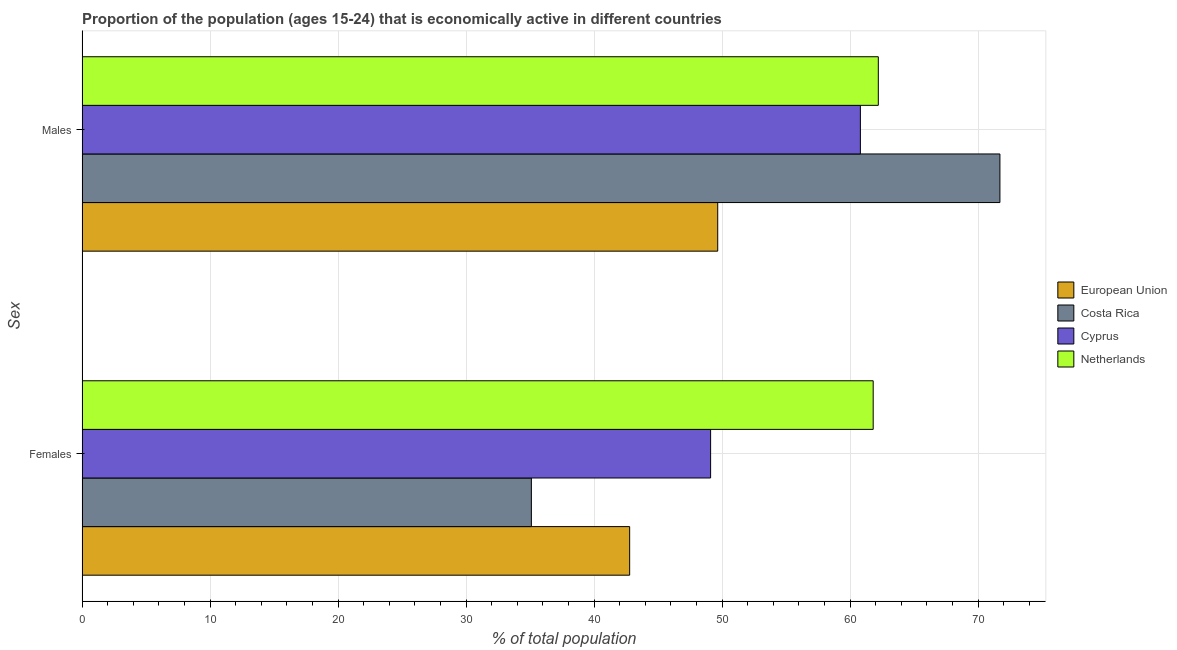How many groups of bars are there?
Make the answer very short. 2. Are the number of bars on each tick of the Y-axis equal?
Give a very brief answer. Yes. How many bars are there on the 1st tick from the bottom?
Ensure brevity in your answer.  4. What is the label of the 1st group of bars from the top?
Offer a very short reply. Males. What is the percentage of economically active female population in European Union?
Make the answer very short. 42.78. Across all countries, what is the maximum percentage of economically active male population?
Your answer should be very brief. 71.7. Across all countries, what is the minimum percentage of economically active male population?
Your response must be concise. 49.66. In which country was the percentage of economically active female population maximum?
Ensure brevity in your answer.  Netherlands. What is the total percentage of economically active male population in the graph?
Your answer should be very brief. 244.36. What is the difference between the percentage of economically active male population in Netherlands and that in European Union?
Make the answer very short. 12.54. What is the difference between the percentage of economically active male population in Netherlands and the percentage of economically active female population in European Union?
Offer a terse response. 19.42. What is the average percentage of economically active female population per country?
Your response must be concise. 47.19. What is the difference between the percentage of economically active male population and percentage of economically active female population in Netherlands?
Make the answer very short. 0.4. What is the ratio of the percentage of economically active male population in Cyprus to that in European Union?
Your answer should be compact. 1.22. What does the 4th bar from the bottom in Males represents?
Provide a succinct answer. Netherlands. How many bars are there?
Your response must be concise. 8. Are all the bars in the graph horizontal?
Your answer should be very brief. Yes. How many countries are there in the graph?
Provide a succinct answer. 4. What is the difference between two consecutive major ticks on the X-axis?
Make the answer very short. 10. How are the legend labels stacked?
Keep it short and to the point. Vertical. What is the title of the graph?
Keep it short and to the point. Proportion of the population (ages 15-24) that is economically active in different countries. Does "Rwanda" appear as one of the legend labels in the graph?
Provide a short and direct response. No. What is the label or title of the X-axis?
Provide a succinct answer. % of total population. What is the label or title of the Y-axis?
Provide a short and direct response. Sex. What is the % of total population in European Union in Females?
Offer a very short reply. 42.78. What is the % of total population in Costa Rica in Females?
Keep it short and to the point. 35.1. What is the % of total population in Cyprus in Females?
Offer a very short reply. 49.1. What is the % of total population in Netherlands in Females?
Your answer should be very brief. 61.8. What is the % of total population of European Union in Males?
Offer a terse response. 49.66. What is the % of total population of Costa Rica in Males?
Offer a very short reply. 71.7. What is the % of total population of Cyprus in Males?
Keep it short and to the point. 60.8. What is the % of total population in Netherlands in Males?
Offer a terse response. 62.2. Across all Sex, what is the maximum % of total population of European Union?
Give a very brief answer. 49.66. Across all Sex, what is the maximum % of total population of Costa Rica?
Offer a very short reply. 71.7. Across all Sex, what is the maximum % of total population in Cyprus?
Give a very brief answer. 60.8. Across all Sex, what is the maximum % of total population of Netherlands?
Give a very brief answer. 62.2. Across all Sex, what is the minimum % of total population in European Union?
Your response must be concise. 42.78. Across all Sex, what is the minimum % of total population of Costa Rica?
Provide a succinct answer. 35.1. Across all Sex, what is the minimum % of total population in Cyprus?
Give a very brief answer. 49.1. Across all Sex, what is the minimum % of total population of Netherlands?
Your answer should be compact. 61.8. What is the total % of total population of European Union in the graph?
Give a very brief answer. 92.43. What is the total % of total population in Costa Rica in the graph?
Provide a short and direct response. 106.8. What is the total % of total population of Cyprus in the graph?
Your answer should be compact. 109.9. What is the total % of total population in Netherlands in the graph?
Give a very brief answer. 124. What is the difference between the % of total population of European Union in Females and that in Males?
Your response must be concise. -6.88. What is the difference between the % of total population in Costa Rica in Females and that in Males?
Offer a very short reply. -36.6. What is the difference between the % of total population of Cyprus in Females and that in Males?
Make the answer very short. -11.7. What is the difference between the % of total population in Netherlands in Females and that in Males?
Provide a short and direct response. -0.4. What is the difference between the % of total population of European Union in Females and the % of total population of Costa Rica in Males?
Ensure brevity in your answer.  -28.92. What is the difference between the % of total population of European Union in Females and the % of total population of Cyprus in Males?
Your response must be concise. -18.02. What is the difference between the % of total population in European Union in Females and the % of total population in Netherlands in Males?
Provide a succinct answer. -19.42. What is the difference between the % of total population in Costa Rica in Females and the % of total population in Cyprus in Males?
Make the answer very short. -25.7. What is the difference between the % of total population in Costa Rica in Females and the % of total population in Netherlands in Males?
Offer a very short reply. -27.1. What is the average % of total population of European Union per Sex?
Keep it short and to the point. 46.22. What is the average % of total population in Costa Rica per Sex?
Provide a short and direct response. 53.4. What is the average % of total population in Cyprus per Sex?
Offer a terse response. 54.95. What is the average % of total population of Netherlands per Sex?
Offer a terse response. 62. What is the difference between the % of total population of European Union and % of total population of Costa Rica in Females?
Keep it short and to the point. 7.68. What is the difference between the % of total population in European Union and % of total population in Cyprus in Females?
Offer a very short reply. -6.32. What is the difference between the % of total population in European Union and % of total population in Netherlands in Females?
Make the answer very short. -19.02. What is the difference between the % of total population of Costa Rica and % of total population of Cyprus in Females?
Provide a short and direct response. -14. What is the difference between the % of total population of Costa Rica and % of total population of Netherlands in Females?
Your answer should be very brief. -26.7. What is the difference between the % of total population in Cyprus and % of total population in Netherlands in Females?
Make the answer very short. -12.7. What is the difference between the % of total population in European Union and % of total population in Costa Rica in Males?
Provide a short and direct response. -22.04. What is the difference between the % of total population in European Union and % of total population in Cyprus in Males?
Keep it short and to the point. -11.14. What is the difference between the % of total population of European Union and % of total population of Netherlands in Males?
Your response must be concise. -12.54. What is the difference between the % of total population in Costa Rica and % of total population in Cyprus in Males?
Ensure brevity in your answer.  10.9. What is the difference between the % of total population of Costa Rica and % of total population of Netherlands in Males?
Make the answer very short. 9.5. What is the difference between the % of total population of Cyprus and % of total population of Netherlands in Males?
Provide a short and direct response. -1.4. What is the ratio of the % of total population in European Union in Females to that in Males?
Make the answer very short. 0.86. What is the ratio of the % of total population of Costa Rica in Females to that in Males?
Your answer should be very brief. 0.49. What is the ratio of the % of total population in Cyprus in Females to that in Males?
Your response must be concise. 0.81. What is the ratio of the % of total population in Netherlands in Females to that in Males?
Provide a short and direct response. 0.99. What is the difference between the highest and the second highest % of total population in European Union?
Your answer should be compact. 6.88. What is the difference between the highest and the second highest % of total population in Costa Rica?
Provide a succinct answer. 36.6. What is the difference between the highest and the second highest % of total population in Netherlands?
Offer a very short reply. 0.4. What is the difference between the highest and the lowest % of total population in European Union?
Your answer should be compact. 6.88. What is the difference between the highest and the lowest % of total population of Costa Rica?
Make the answer very short. 36.6. 